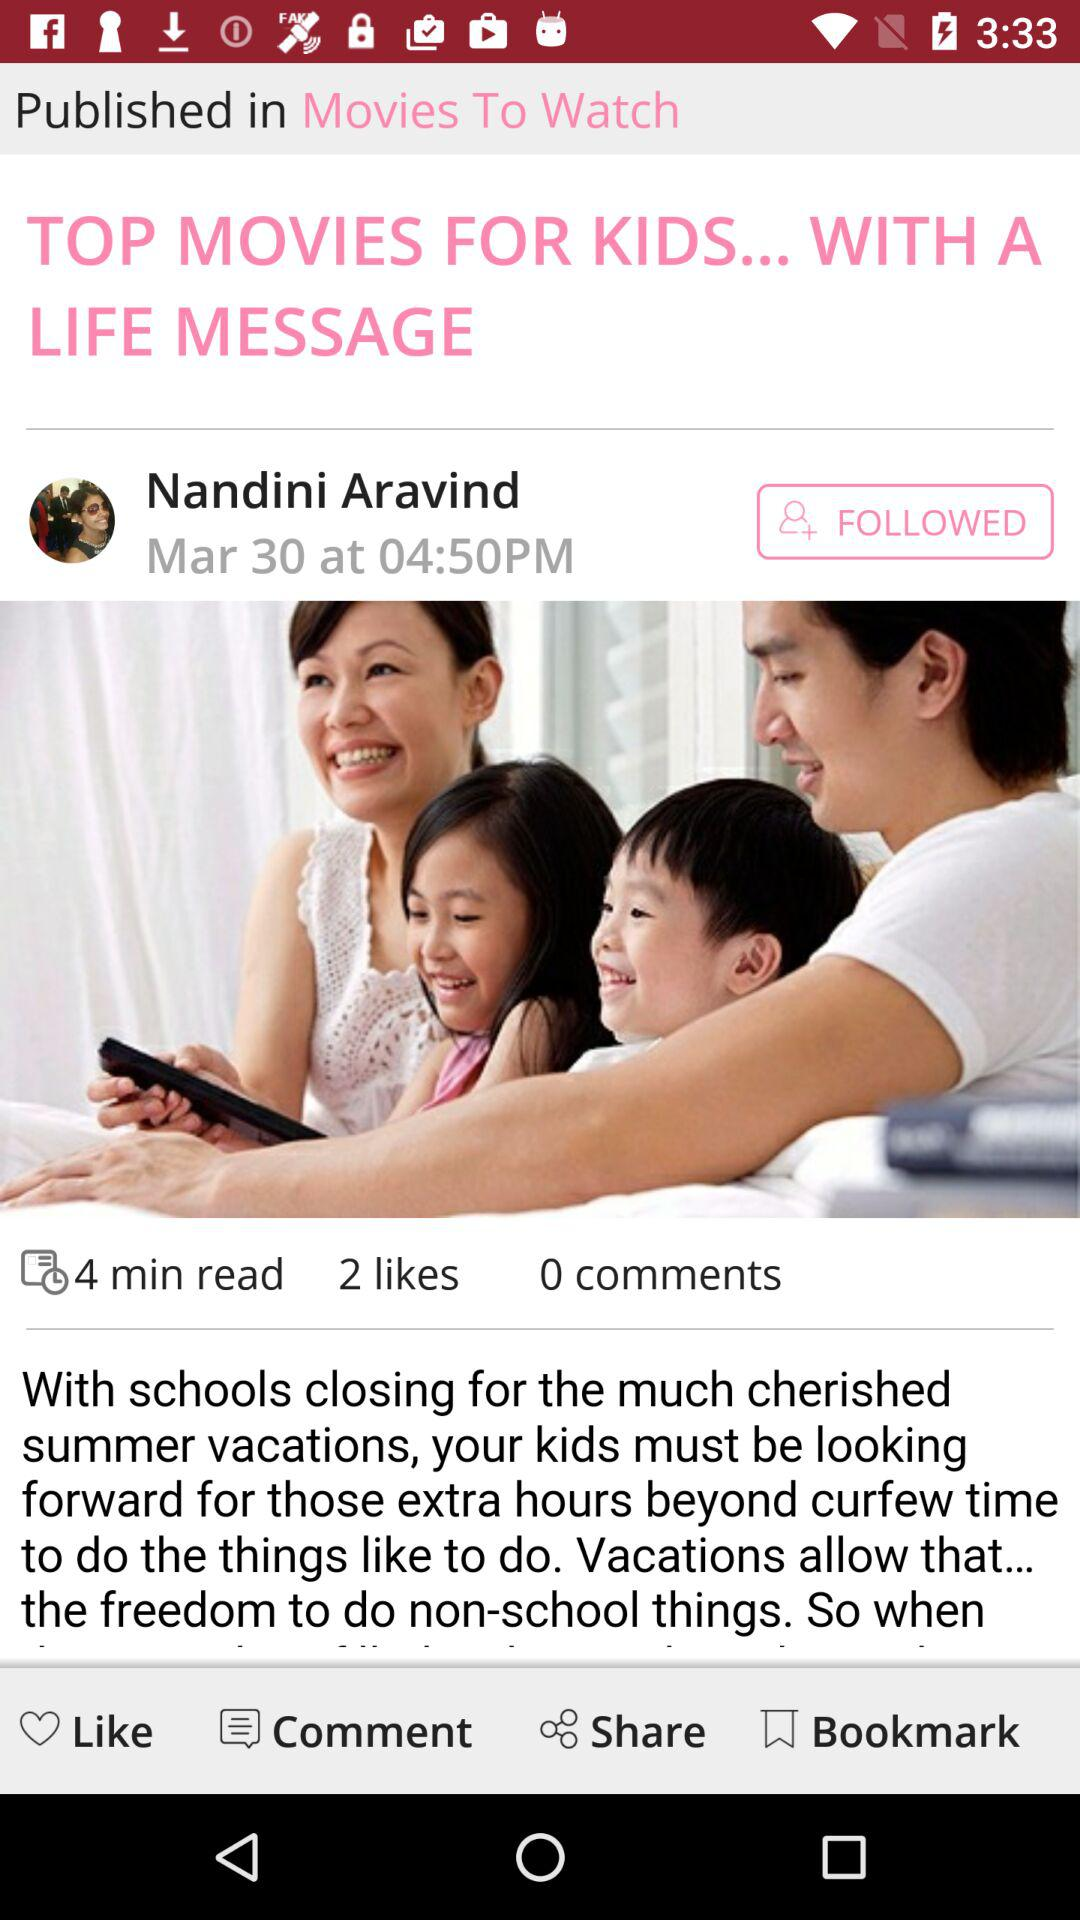How many likes are there? There are 2 likes. 